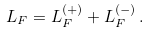<formula> <loc_0><loc_0><loc_500><loc_500>L _ { F } = L _ { F } ^ { ( + ) } + L _ { F } ^ { ( - ) } \, .</formula> 